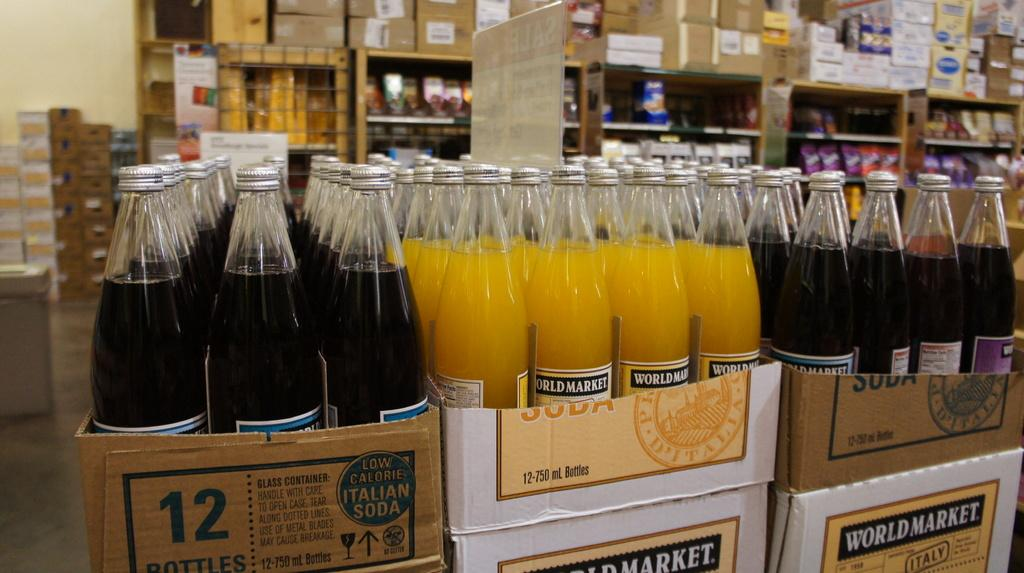<image>
Present a compact description of the photo's key features. Bottles of world market soft drink in a cardboard box. 